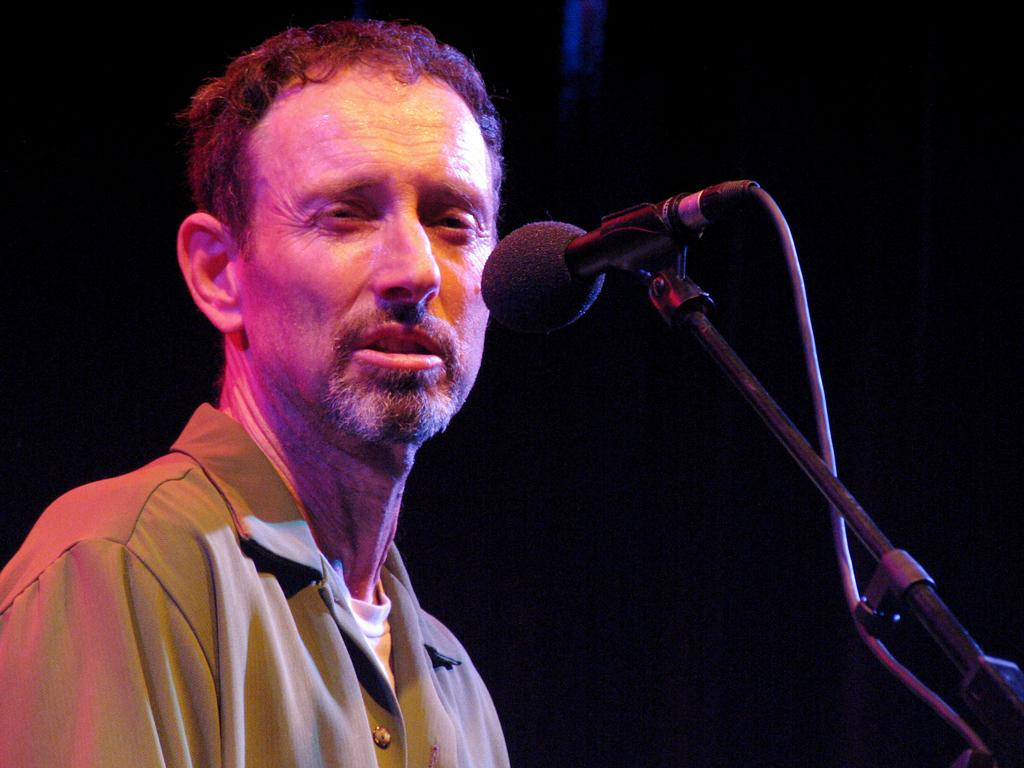Who is the main subject in the image? There is a man in the image. What object is in front of the man? There is a mic with a stand in front of the man. What can be observed about the background of the image? The background of the image is dark. What type of collar is the man wearing in the image? There is no collar visible in the image, as the man is not wearing any clothing. What government policy is being discussed in the image? There is no indication of a discussion about government policy in the image. 